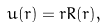Convert formula to latex. <formula><loc_0><loc_0><loc_500><loc_500>u ( r ) = r R ( r ) ,</formula> 